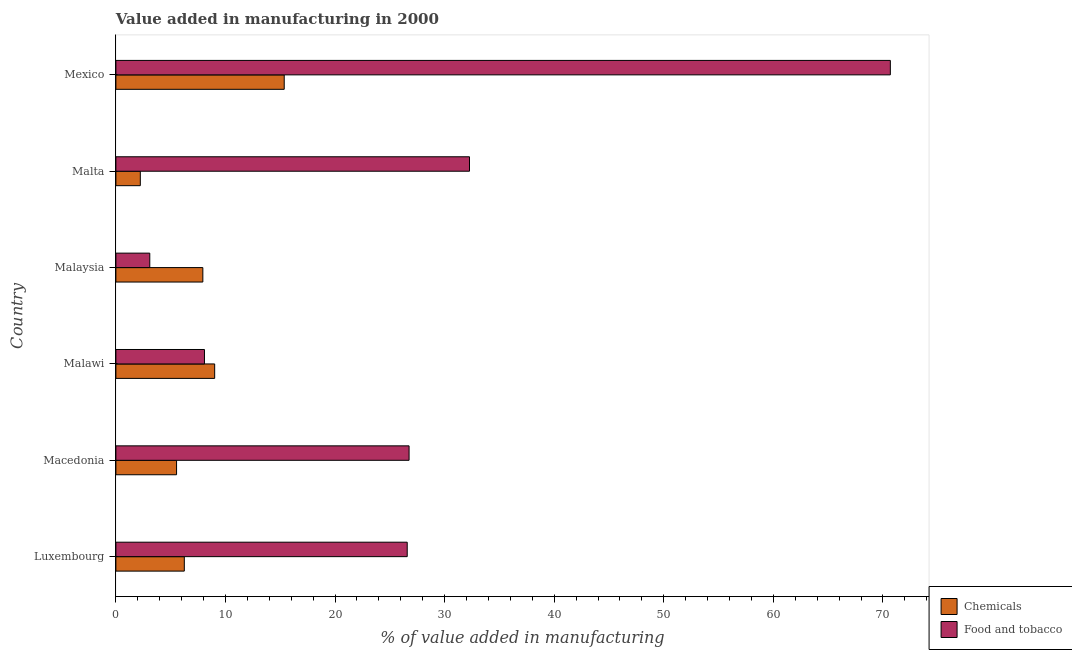Are the number of bars per tick equal to the number of legend labels?
Offer a very short reply. Yes. What is the label of the 1st group of bars from the top?
Provide a succinct answer. Mexico. What is the value added by manufacturing food and tobacco in Luxembourg?
Keep it short and to the point. 26.59. Across all countries, what is the maximum value added by manufacturing food and tobacco?
Offer a very short reply. 70.67. Across all countries, what is the minimum value added by  manufacturing chemicals?
Give a very brief answer. 2.23. In which country was the value added by  manufacturing chemicals minimum?
Ensure brevity in your answer.  Malta. What is the total value added by  manufacturing chemicals in the graph?
Ensure brevity in your answer.  46.32. What is the difference between the value added by  manufacturing chemicals in Macedonia and that in Malta?
Your response must be concise. 3.31. What is the difference between the value added by manufacturing food and tobacco in Mexico and the value added by  manufacturing chemicals in Malawi?
Give a very brief answer. 61.66. What is the average value added by manufacturing food and tobacco per country?
Your response must be concise. 27.91. What is the difference between the value added by manufacturing food and tobacco and value added by  manufacturing chemicals in Macedonia?
Make the answer very short. 21.22. What is the ratio of the value added by  manufacturing chemicals in Malawi to that in Malaysia?
Your answer should be compact. 1.14. What is the difference between the highest and the second highest value added by manufacturing food and tobacco?
Your answer should be very brief. 38.41. What is the difference between the highest and the lowest value added by manufacturing food and tobacco?
Offer a terse response. 67.58. What does the 1st bar from the top in Malta represents?
Offer a very short reply. Food and tobacco. What does the 2nd bar from the bottom in Mexico represents?
Give a very brief answer. Food and tobacco. How many countries are there in the graph?
Your answer should be compact. 6. What is the difference between two consecutive major ticks on the X-axis?
Keep it short and to the point. 10. Does the graph contain any zero values?
Ensure brevity in your answer.  No. Where does the legend appear in the graph?
Provide a succinct answer. Bottom right. How many legend labels are there?
Make the answer very short. 2. What is the title of the graph?
Provide a short and direct response. Value added in manufacturing in 2000. What is the label or title of the X-axis?
Provide a succinct answer. % of value added in manufacturing. What is the % of value added in manufacturing of Chemicals in Luxembourg?
Offer a very short reply. 6.24. What is the % of value added in manufacturing in Food and tobacco in Luxembourg?
Provide a succinct answer. 26.59. What is the % of value added in manufacturing of Chemicals in Macedonia?
Your answer should be very brief. 5.54. What is the % of value added in manufacturing in Food and tobacco in Macedonia?
Ensure brevity in your answer.  26.76. What is the % of value added in manufacturing of Chemicals in Malawi?
Your response must be concise. 9.01. What is the % of value added in manufacturing of Food and tobacco in Malawi?
Make the answer very short. 8.08. What is the % of value added in manufacturing in Chemicals in Malaysia?
Your response must be concise. 7.93. What is the % of value added in manufacturing of Food and tobacco in Malaysia?
Your answer should be very brief. 3.09. What is the % of value added in manufacturing of Chemicals in Malta?
Your answer should be very brief. 2.23. What is the % of value added in manufacturing in Food and tobacco in Malta?
Your response must be concise. 32.27. What is the % of value added in manufacturing in Chemicals in Mexico?
Provide a succinct answer. 15.36. What is the % of value added in manufacturing of Food and tobacco in Mexico?
Ensure brevity in your answer.  70.67. Across all countries, what is the maximum % of value added in manufacturing in Chemicals?
Your answer should be very brief. 15.36. Across all countries, what is the maximum % of value added in manufacturing in Food and tobacco?
Keep it short and to the point. 70.67. Across all countries, what is the minimum % of value added in manufacturing of Chemicals?
Make the answer very short. 2.23. Across all countries, what is the minimum % of value added in manufacturing in Food and tobacco?
Offer a very short reply. 3.09. What is the total % of value added in manufacturing in Chemicals in the graph?
Your response must be concise. 46.32. What is the total % of value added in manufacturing of Food and tobacco in the graph?
Give a very brief answer. 167.46. What is the difference between the % of value added in manufacturing in Chemicals in Luxembourg and that in Macedonia?
Offer a very short reply. 0.71. What is the difference between the % of value added in manufacturing in Food and tobacco in Luxembourg and that in Macedonia?
Keep it short and to the point. -0.17. What is the difference between the % of value added in manufacturing in Chemicals in Luxembourg and that in Malawi?
Ensure brevity in your answer.  -2.77. What is the difference between the % of value added in manufacturing of Food and tobacco in Luxembourg and that in Malawi?
Offer a very short reply. 18.5. What is the difference between the % of value added in manufacturing of Chemicals in Luxembourg and that in Malaysia?
Provide a short and direct response. -1.69. What is the difference between the % of value added in manufacturing in Food and tobacco in Luxembourg and that in Malaysia?
Your answer should be very brief. 23.49. What is the difference between the % of value added in manufacturing in Chemicals in Luxembourg and that in Malta?
Give a very brief answer. 4.02. What is the difference between the % of value added in manufacturing of Food and tobacco in Luxembourg and that in Malta?
Give a very brief answer. -5.68. What is the difference between the % of value added in manufacturing of Chemicals in Luxembourg and that in Mexico?
Your answer should be compact. -9.12. What is the difference between the % of value added in manufacturing of Food and tobacco in Luxembourg and that in Mexico?
Offer a very short reply. -44.09. What is the difference between the % of value added in manufacturing of Chemicals in Macedonia and that in Malawi?
Provide a succinct answer. -3.48. What is the difference between the % of value added in manufacturing of Food and tobacco in Macedonia and that in Malawi?
Provide a succinct answer. 18.67. What is the difference between the % of value added in manufacturing in Chemicals in Macedonia and that in Malaysia?
Provide a short and direct response. -2.4. What is the difference between the % of value added in manufacturing in Food and tobacco in Macedonia and that in Malaysia?
Offer a very short reply. 23.66. What is the difference between the % of value added in manufacturing in Chemicals in Macedonia and that in Malta?
Your response must be concise. 3.31. What is the difference between the % of value added in manufacturing in Food and tobacco in Macedonia and that in Malta?
Offer a terse response. -5.51. What is the difference between the % of value added in manufacturing in Chemicals in Macedonia and that in Mexico?
Keep it short and to the point. -9.82. What is the difference between the % of value added in manufacturing of Food and tobacco in Macedonia and that in Mexico?
Your answer should be very brief. -43.92. What is the difference between the % of value added in manufacturing of Chemicals in Malawi and that in Malaysia?
Ensure brevity in your answer.  1.08. What is the difference between the % of value added in manufacturing in Food and tobacco in Malawi and that in Malaysia?
Offer a very short reply. 4.99. What is the difference between the % of value added in manufacturing of Chemicals in Malawi and that in Malta?
Provide a short and direct response. 6.79. What is the difference between the % of value added in manufacturing in Food and tobacco in Malawi and that in Malta?
Provide a succinct answer. -24.19. What is the difference between the % of value added in manufacturing in Chemicals in Malawi and that in Mexico?
Offer a very short reply. -6.35. What is the difference between the % of value added in manufacturing in Food and tobacco in Malawi and that in Mexico?
Provide a succinct answer. -62.59. What is the difference between the % of value added in manufacturing of Chemicals in Malaysia and that in Malta?
Your response must be concise. 5.71. What is the difference between the % of value added in manufacturing of Food and tobacco in Malaysia and that in Malta?
Provide a succinct answer. -29.18. What is the difference between the % of value added in manufacturing in Chemicals in Malaysia and that in Mexico?
Provide a succinct answer. -7.43. What is the difference between the % of value added in manufacturing in Food and tobacco in Malaysia and that in Mexico?
Your response must be concise. -67.58. What is the difference between the % of value added in manufacturing in Chemicals in Malta and that in Mexico?
Provide a short and direct response. -13.13. What is the difference between the % of value added in manufacturing of Food and tobacco in Malta and that in Mexico?
Offer a terse response. -38.4. What is the difference between the % of value added in manufacturing in Chemicals in Luxembourg and the % of value added in manufacturing in Food and tobacco in Macedonia?
Your response must be concise. -20.51. What is the difference between the % of value added in manufacturing of Chemicals in Luxembourg and the % of value added in manufacturing of Food and tobacco in Malawi?
Give a very brief answer. -1.84. What is the difference between the % of value added in manufacturing in Chemicals in Luxembourg and the % of value added in manufacturing in Food and tobacco in Malaysia?
Your response must be concise. 3.15. What is the difference between the % of value added in manufacturing of Chemicals in Luxembourg and the % of value added in manufacturing of Food and tobacco in Malta?
Provide a short and direct response. -26.02. What is the difference between the % of value added in manufacturing of Chemicals in Luxembourg and the % of value added in manufacturing of Food and tobacco in Mexico?
Provide a short and direct response. -64.43. What is the difference between the % of value added in manufacturing of Chemicals in Macedonia and the % of value added in manufacturing of Food and tobacco in Malawi?
Provide a succinct answer. -2.55. What is the difference between the % of value added in manufacturing in Chemicals in Macedonia and the % of value added in manufacturing in Food and tobacco in Malaysia?
Provide a succinct answer. 2.44. What is the difference between the % of value added in manufacturing in Chemicals in Macedonia and the % of value added in manufacturing in Food and tobacco in Malta?
Ensure brevity in your answer.  -26.73. What is the difference between the % of value added in manufacturing in Chemicals in Macedonia and the % of value added in manufacturing in Food and tobacco in Mexico?
Ensure brevity in your answer.  -65.14. What is the difference between the % of value added in manufacturing in Chemicals in Malawi and the % of value added in manufacturing in Food and tobacco in Malaysia?
Offer a terse response. 5.92. What is the difference between the % of value added in manufacturing of Chemicals in Malawi and the % of value added in manufacturing of Food and tobacco in Malta?
Make the answer very short. -23.25. What is the difference between the % of value added in manufacturing in Chemicals in Malawi and the % of value added in manufacturing in Food and tobacco in Mexico?
Ensure brevity in your answer.  -61.66. What is the difference between the % of value added in manufacturing of Chemicals in Malaysia and the % of value added in manufacturing of Food and tobacco in Malta?
Make the answer very short. -24.33. What is the difference between the % of value added in manufacturing of Chemicals in Malaysia and the % of value added in manufacturing of Food and tobacco in Mexico?
Your answer should be very brief. -62.74. What is the difference between the % of value added in manufacturing in Chemicals in Malta and the % of value added in manufacturing in Food and tobacco in Mexico?
Provide a short and direct response. -68.44. What is the average % of value added in manufacturing of Chemicals per country?
Offer a terse response. 7.72. What is the average % of value added in manufacturing in Food and tobacco per country?
Give a very brief answer. 27.91. What is the difference between the % of value added in manufacturing of Chemicals and % of value added in manufacturing of Food and tobacco in Luxembourg?
Offer a very short reply. -20.34. What is the difference between the % of value added in manufacturing of Chemicals and % of value added in manufacturing of Food and tobacco in Macedonia?
Make the answer very short. -21.22. What is the difference between the % of value added in manufacturing in Chemicals and % of value added in manufacturing in Food and tobacco in Malawi?
Your answer should be very brief. 0.93. What is the difference between the % of value added in manufacturing in Chemicals and % of value added in manufacturing in Food and tobacco in Malaysia?
Provide a short and direct response. 4.84. What is the difference between the % of value added in manufacturing in Chemicals and % of value added in manufacturing in Food and tobacco in Malta?
Provide a succinct answer. -30.04. What is the difference between the % of value added in manufacturing in Chemicals and % of value added in manufacturing in Food and tobacco in Mexico?
Give a very brief answer. -55.31. What is the ratio of the % of value added in manufacturing of Chemicals in Luxembourg to that in Macedonia?
Offer a terse response. 1.13. What is the ratio of the % of value added in manufacturing in Chemicals in Luxembourg to that in Malawi?
Offer a terse response. 0.69. What is the ratio of the % of value added in manufacturing in Food and tobacco in Luxembourg to that in Malawi?
Ensure brevity in your answer.  3.29. What is the ratio of the % of value added in manufacturing of Chemicals in Luxembourg to that in Malaysia?
Your response must be concise. 0.79. What is the ratio of the % of value added in manufacturing of Food and tobacco in Luxembourg to that in Malaysia?
Make the answer very short. 8.6. What is the ratio of the % of value added in manufacturing of Chemicals in Luxembourg to that in Malta?
Offer a terse response. 2.8. What is the ratio of the % of value added in manufacturing of Food and tobacco in Luxembourg to that in Malta?
Offer a terse response. 0.82. What is the ratio of the % of value added in manufacturing in Chemicals in Luxembourg to that in Mexico?
Ensure brevity in your answer.  0.41. What is the ratio of the % of value added in manufacturing in Food and tobacco in Luxembourg to that in Mexico?
Your response must be concise. 0.38. What is the ratio of the % of value added in manufacturing of Chemicals in Macedonia to that in Malawi?
Your response must be concise. 0.61. What is the ratio of the % of value added in manufacturing of Food and tobacco in Macedonia to that in Malawi?
Ensure brevity in your answer.  3.31. What is the ratio of the % of value added in manufacturing in Chemicals in Macedonia to that in Malaysia?
Your answer should be very brief. 0.7. What is the ratio of the % of value added in manufacturing in Food and tobacco in Macedonia to that in Malaysia?
Give a very brief answer. 8.65. What is the ratio of the % of value added in manufacturing of Chemicals in Macedonia to that in Malta?
Offer a very short reply. 2.48. What is the ratio of the % of value added in manufacturing of Food and tobacco in Macedonia to that in Malta?
Offer a very short reply. 0.83. What is the ratio of the % of value added in manufacturing of Chemicals in Macedonia to that in Mexico?
Your answer should be compact. 0.36. What is the ratio of the % of value added in manufacturing in Food and tobacco in Macedonia to that in Mexico?
Keep it short and to the point. 0.38. What is the ratio of the % of value added in manufacturing in Chemicals in Malawi to that in Malaysia?
Offer a very short reply. 1.14. What is the ratio of the % of value added in manufacturing in Food and tobacco in Malawi to that in Malaysia?
Your answer should be very brief. 2.61. What is the ratio of the % of value added in manufacturing in Chemicals in Malawi to that in Malta?
Ensure brevity in your answer.  4.04. What is the ratio of the % of value added in manufacturing in Food and tobacco in Malawi to that in Malta?
Give a very brief answer. 0.25. What is the ratio of the % of value added in manufacturing in Chemicals in Malawi to that in Mexico?
Provide a short and direct response. 0.59. What is the ratio of the % of value added in manufacturing in Food and tobacco in Malawi to that in Mexico?
Ensure brevity in your answer.  0.11. What is the ratio of the % of value added in manufacturing of Chemicals in Malaysia to that in Malta?
Your answer should be compact. 3.56. What is the ratio of the % of value added in manufacturing in Food and tobacco in Malaysia to that in Malta?
Your answer should be very brief. 0.1. What is the ratio of the % of value added in manufacturing of Chemicals in Malaysia to that in Mexico?
Provide a short and direct response. 0.52. What is the ratio of the % of value added in manufacturing in Food and tobacco in Malaysia to that in Mexico?
Keep it short and to the point. 0.04. What is the ratio of the % of value added in manufacturing of Chemicals in Malta to that in Mexico?
Give a very brief answer. 0.15. What is the ratio of the % of value added in manufacturing of Food and tobacco in Malta to that in Mexico?
Your answer should be very brief. 0.46. What is the difference between the highest and the second highest % of value added in manufacturing of Chemicals?
Make the answer very short. 6.35. What is the difference between the highest and the second highest % of value added in manufacturing of Food and tobacco?
Make the answer very short. 38.4. What is the difference between the highest and the lowest % of value added in manufacturing of Chemicals?
Provide a succinct answer. 13.13. What is the difference between the highest and the lowest % of value added in manufacturing of Food and tobacco?
Make the answer very short. 67.58. 